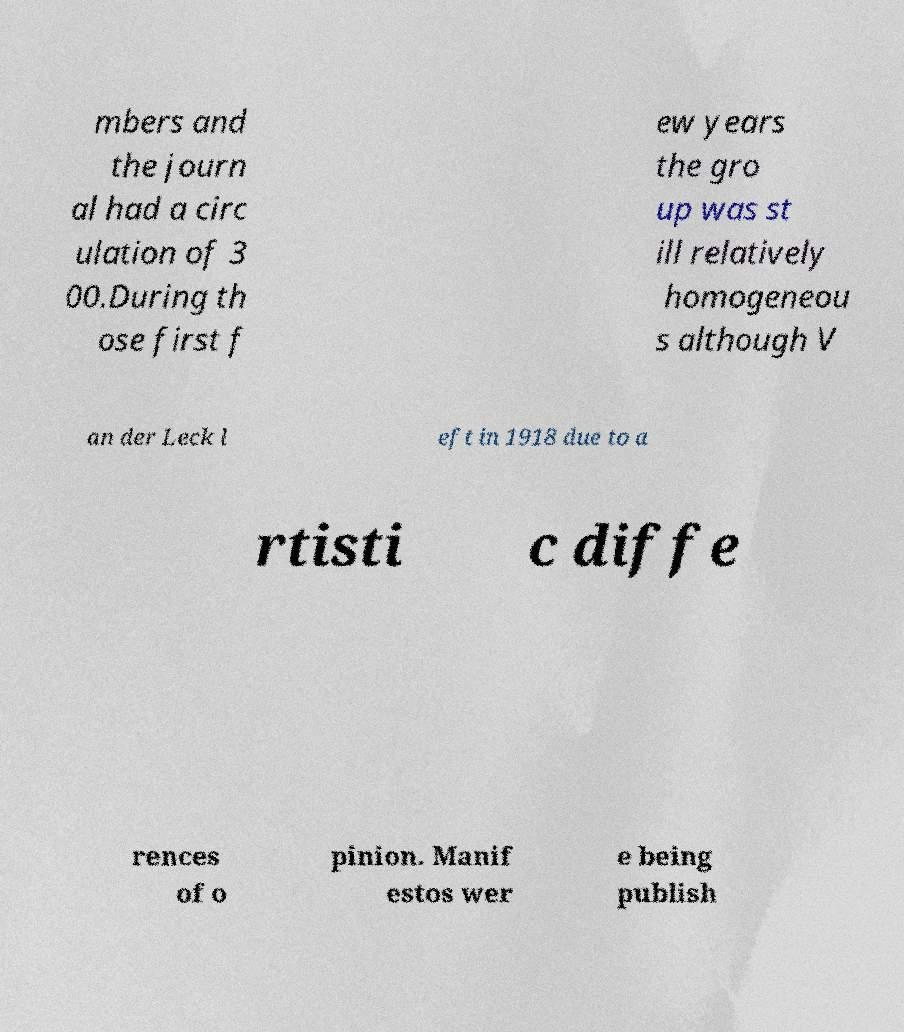I need the written content from this picture converted into text. Can you do that? mbers and the journ al had a circ ulation of 3 00.During th ose first f ew years the gro up was st ill relatively homogeneou s although V an der Leck l eft in 1918 due to a rtisti c diffe rences of o pinion. Manif estos wer e being publish 